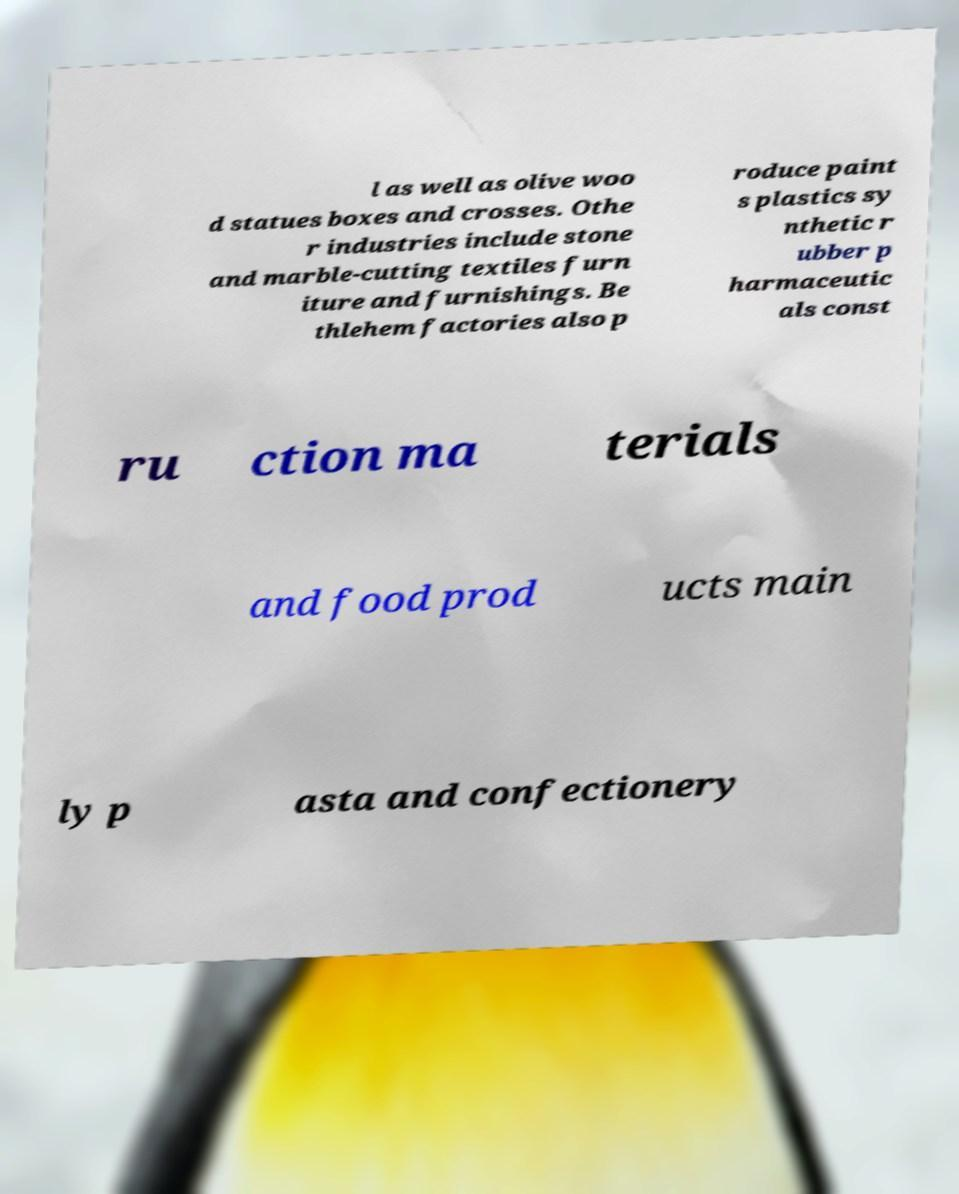Can you accurately transcribe the text from the provided image for me? l as well as olive woo d statues boxes and crosses. Othe r industries include stone and marble-cutting textiles furn iture and furnishings. Be thlehem factories also p roduce paint s plastics sy nthetic r ubber p harmaceutic als const ru ction ma terials and food prod ucts main ly p asta and confectionery 